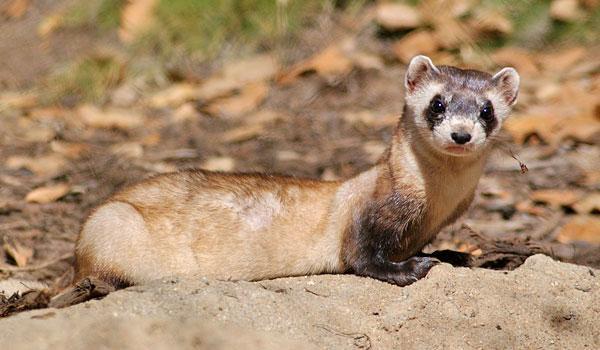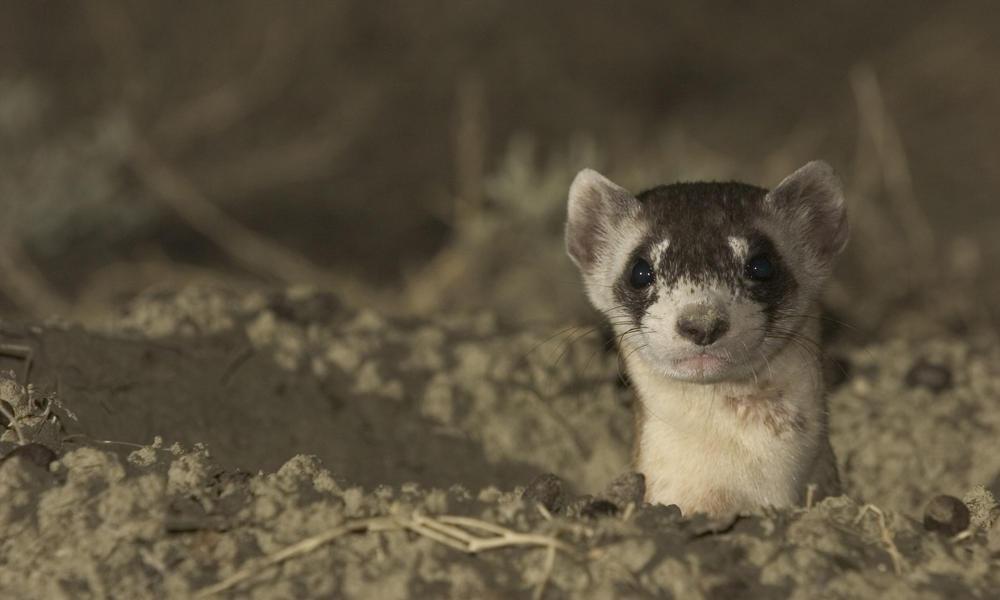The first image is the image on the left, the second image is the image on the right. Analyze the images presented: Is the assertion "The left animal is mostly underground, the right animal is entirely above ground." valid? Answer yes or no. No. 